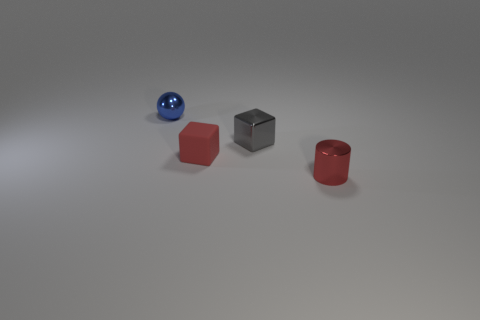Add 1 blue shiny balls. How many objects exist? 5 Subtract all cylinders. How many objects are left? 3 Subtract 0 cyan spheres. How many objects are left? 4 Subtract all large gray matte cylinders. Subtract all red metallic cylinders. How many objects are left? 3 Add 1 metal objects. How many metal objects are left? 4 Add 3 tiny red metal things. How many tiny red metal things exist? 4 